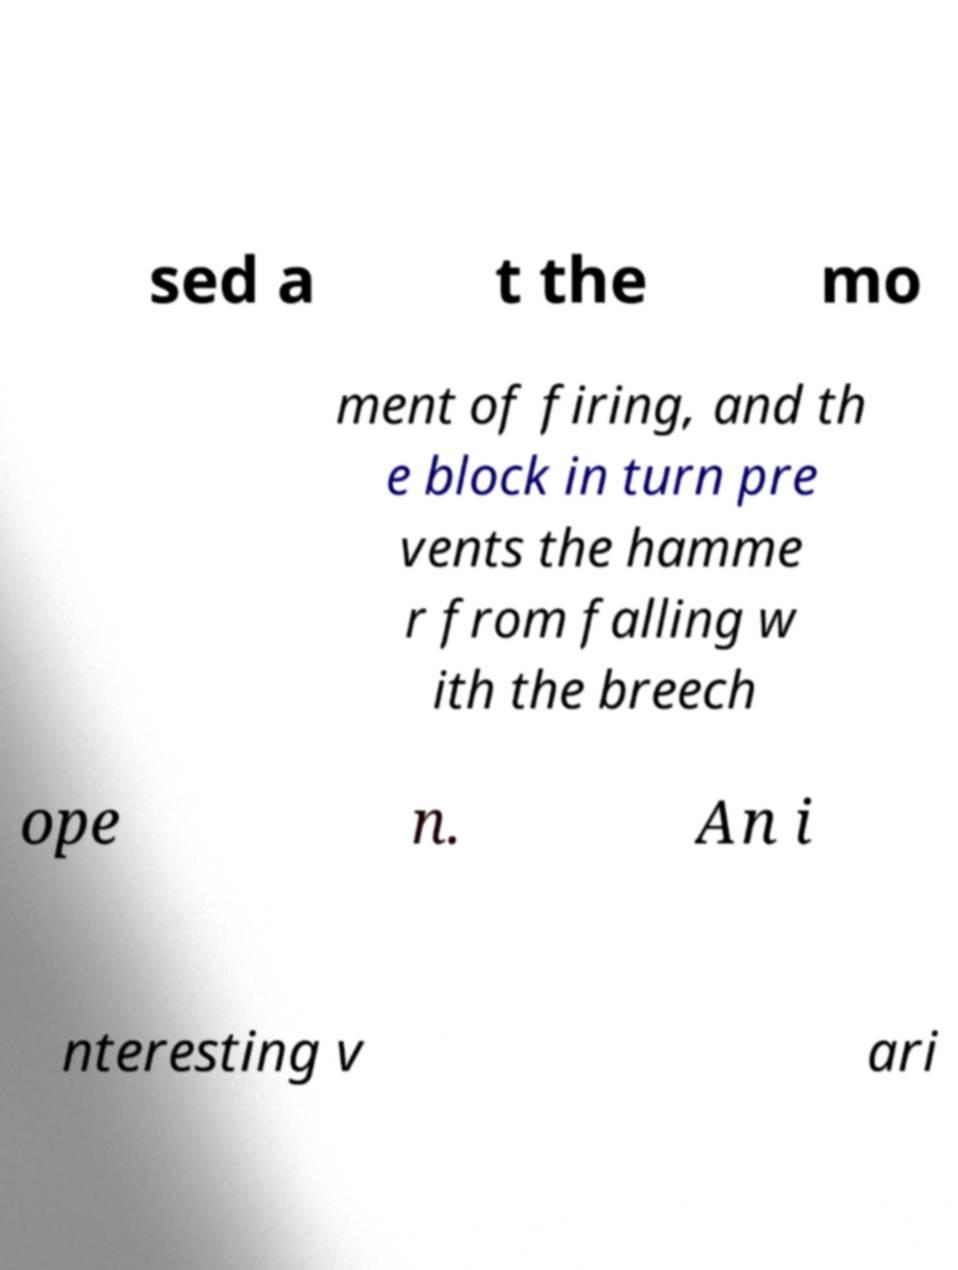There's text embedded in this image that I need extracted. Can you transcribe it verbatim? sed a t the mo ment of firing, and th e block in turn pre vents the hamme r from falling w ith the breech ope n. An i nteresting v ari 